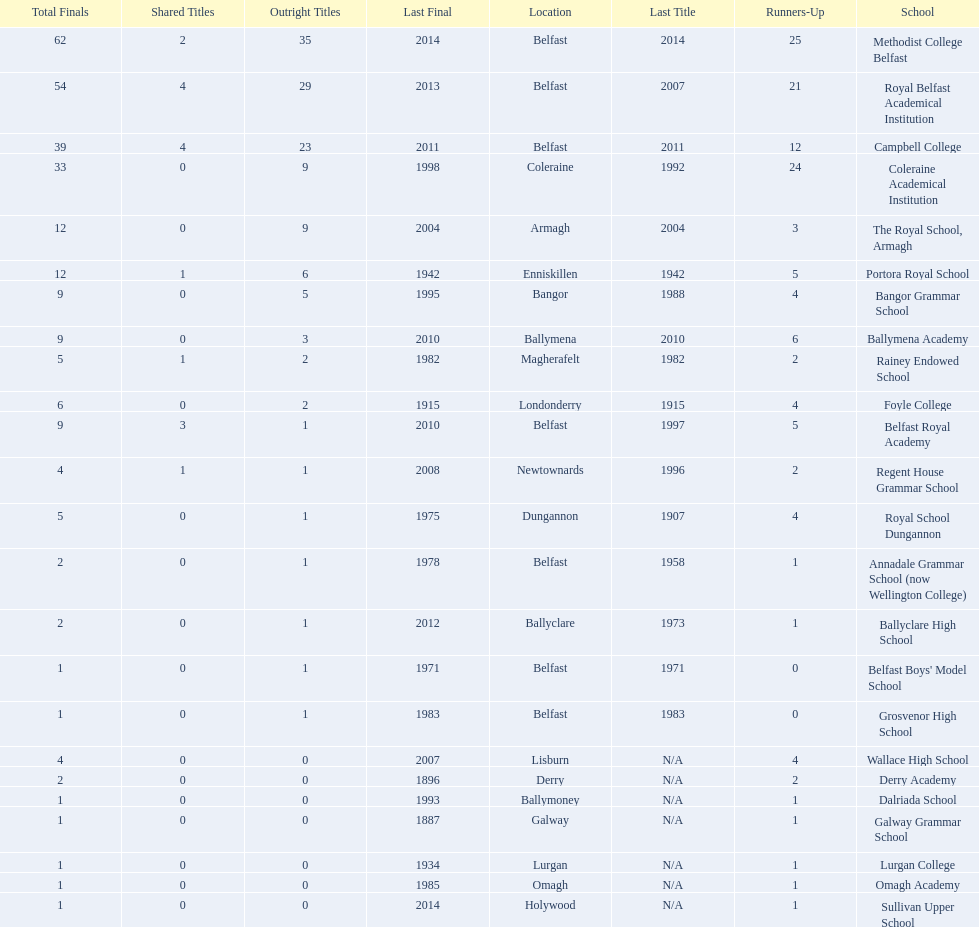How many schools are there? Methodist College Belfast, Royal Belfast Academical Institution, Campbell College, Coleraine Academical Institution, The Royal School, Armagh, Portora Royal School, Bangor Grammar School, Ballymena Academy, Rainey Endowed School, Foyle College, Belfast Royal Academy, Regent House Grammar School, Royal School Dungannon, Annadale Grammar School (now Wellington College), Ballyclare High School, Belfast Boys' Model School, Grosvenor High School, Wallace High School, Derry Academy, Dalriada School, Galway Grammar School, Lurgan College, Omagh Academy, Sullivan Upper School. How many outright titles does the coleraine academical institution have? 9. What other school has the same number of outright titles? The Royal School, Armagh. 